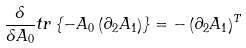<formula> <loc_0><loc_0><loc_500><loc_500>\frac { \delta } { \delta A _ { 0 } } t r \left \{ - A _ { 0 } \left ( \partial _ { 2 } A _ { 1 } \right ) \right \} = - \left ( \partial _ { 2 } A _ { 1 } \right ) ^ { T }</formula> 